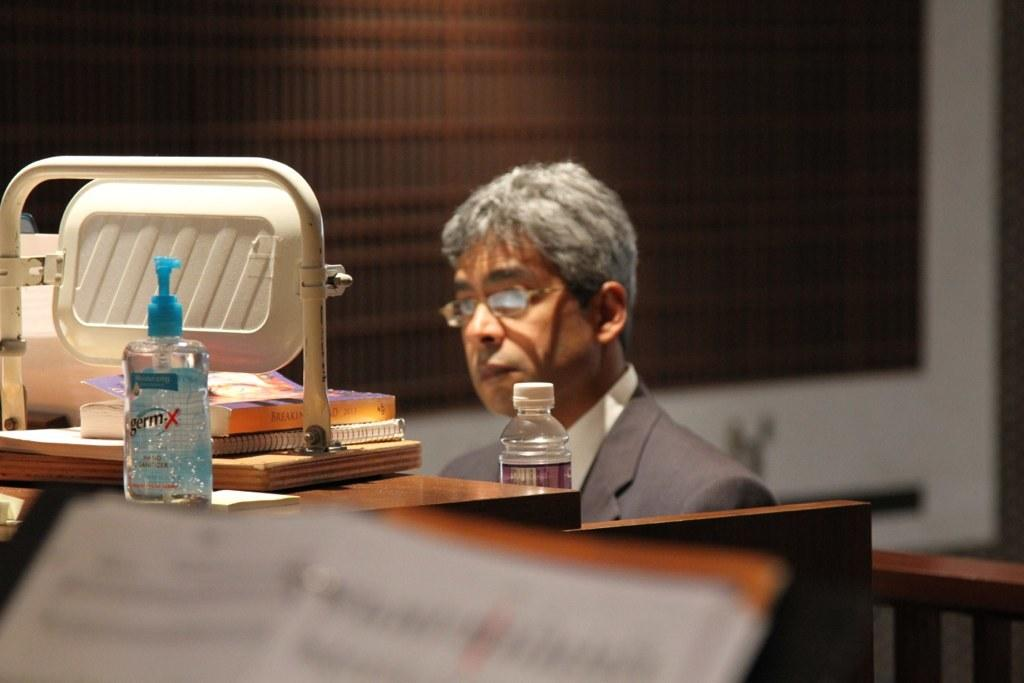<image>
Offer a succinct explanation of the picture presented. a man sitting at a piano with a bottle of germ x on top of it 